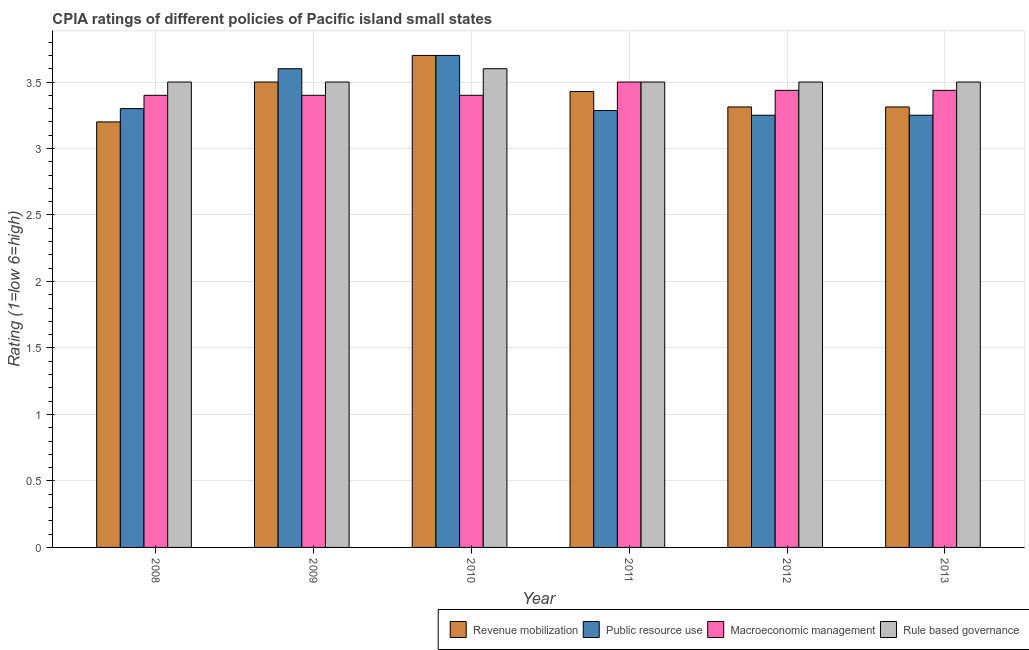How many groups of bars are there?
Ensure brevity in your answer.  6. Are the number of bars per tick equal to the number of legend labels?
Your answer should be very brief. Yes. How many bars are there on the 1st tick from the right?
Offer a very short reply. 4. What is the cpia rating of public resource use in 2011?
Keep it short and to the point. 3.29. Across all years, what is the maximum cpia rating of rule based governance?
Keep it short and to the point. 3.6. In which year was the cpia rating of macroeconomic management maximum?
Your answer should be compact. 2011. What is the total cpia rating of public resource use in the graph?
Your response must be concise. 20.39. What is the difference between the cpia rating of revenue mobilization in 2012 and the cpia rating of rule based governance in 2011?
Your response must be concise. -0.12. What is the average cpia rating of revenue mobilization per year?
Your answer should be very brief. 3.41. What is the ratio of the cpia rating of rule based governance in 2010 to that in 2012?
Ensure brevity in your answer.  1.03. Is the difference between the cpia rating of revenue mobilization in 2009 and 2013 greater than the difference between the cpia rating of rule based governance in 2009 and 2013?
Keep it short and to the point. No. What is the difference between the highest and the second highest cpia rating of rule based governance?
Offer a very short reply. 0.1. What is the difference between the highest and the lowest cpia rating of rule based governance?
Provide a short and direct response. 0.1. Is the sum of the cpia rating of public resource use in 2009 and 2011 greater than the maximum cpia rating of rule based governance across all years?
Keep it short and to the point. Yes. What does the 4th bar from the left in 2011 represents?
Your answer should be compact. Rule based governance. What does the 3rd bar from the right in 2008 represents?
Provide a short and direct response. Public resource use. Is it the case that in every year, the sum of the cpia rating of revenue mobilization and cpia rating of public resource use is greater than the cpia rating of macroeconomic management?
Make the answer very short. Yes. Are all the bars in the graph horizontal?
Your response must be concise. No. How many years are there in the graph?
Your answer should be compact. 6. Are the values on the major ticks of Y-axis written in scientific E-notation?
Make the answer very short. No. Does the graph contain any zero values?
Keep it short and to the point. No. How are the legend labels stacked?
Offer a very short reply. Horizontal. What is the title of the graph?
Your answer should be compact. CPIA ratings of different policies of Pacific island small states. What is the label or title of the Y-axis?
Give a very brief answer. Rating (1=low 6=high). What is the Rating (1=low 6=high) in Revenue mobilization in 2008?
Offer a very short reply. 3.2. What is the Rating (1=low 6=high) in Public resource use in 2008?
Your response must be concise. 3.3. What is the Rating (1=low 6=high) of Macroeconomic management in 2008?
Offer a very short reply. 3.4. What is the Rating (1=low 6=high) of Revenue mobilization in 2009?
Offer a terse response. 3.5. What is the Rating (1=low 6=high) in Public resource use in 2009?
Your response must be concise. 3.6. What is the Rating (1=low 6=high) of Revenue mobilization in 2010?
Provide a succinct answer. 3.7. What is the Rating (1=low 6=high) in Rule based governance in 2010?
Your answer should be very brief. 3.6. What is the Rating (1=low 6=high) in Revenue mobilization in 2011?
Give a very brief answer. 3.43. What is the Rating (1=low 6=high) in Public resource use in 2011?
Provide a succinct answer. 3.29. What is the Rating (1=low 6=high) of Macroeconomic management in 2011?
Your answer should be very brief. 3.5. What is the Rating (1=low 6=high) of Rule based governance in 2011?
Make the answer very short. 3.5. What is the Rating (1=low 6=high) of Revenue mobilization in 2012?
Your answer should be compact. 3.31. What is the Rating (1=low 6=high) in Macroeconomic management in 2012?
Offer a terse response. 3.44. What is the Rating (1=low 6=high) of Rule based governance in 2012?
Your answer should be compact. 3.5. What is the Rating (1=low 6=high) in Revenue mobilization in 2013?
Your response must be concise. 3.31. What is the Rating (1=low 6=high) of Public resource use in 2013?
Offer a very short reply. 3.25. What is the Rating (1=low 6=high) in Macroeconomic management in 2013?
Give a very brief answer. 3.44. Across all years, what is the maximum Rating (1=low 6=high) of Macroeconomic management?
Provide a short and direct response. 3.5. Across all years, what is the minimum Rating (1=low 6=high) in Macroeconomic management?
Make the answer very short. 3.4. What is the total Rating (1=low 6=high) of Revenue mobilization in the graph?
Provide a succinct answer. 20.45. What is the total Rating (1=low 6=high) in Public resource use in the graph?
Your answer should be very brief. 20.39. What is the total Rating (1=low 6=high) of Macroeconomic management in the graph?
Your answer should be very brief. 20.57. What is the total Rating (1=low 6=high) of Rule based governance in the graph?
Provide a short and direct response. 21.1. What is the difference between the Rating (1=low 6=high) of Public resource use in 2008 and that in 2009?
Give a very brief answer. -0.3. What is the difference between the Rating (1=low 6=high) of Macroeconomic management in 2008 and that in 2009?
Your response must be concise. 0. What is the difference between the Rating (1=low 6=high) in Rule based governance in 2008 and that in 2009?
Make the answer very short. 0. What is the difference between the Rating (1=low 6=high) in Macroeconomic management in 2008 and that in 2010?
Provide a succinct answer. 0. What is the difference between the Rating (1=low 6=high) of Rule based governance in 2008 and that in 2010?
Offer a terse response. -0.1. What is the difference between the Rating (1=low 6=high) of Revenue mobilization in 2008 and that in 2011?
Provide a succinct answer. -0.23. What is the difference between the Rating (1=low 6=high) of Public resource use in 2008 and that in 2011?
Provide a short and direct response. 0.01. What is the difference between the Rating (1=low 6=high) of Revenue mobilization in 2008 and that in 2012?
Keep it short and to the point. -0.11. What is the difference between the Rating (1=low 6=high) in Public resource use in 2008 and that in 2012?
Ensure brevity in your answer.  0.05. What is the difference between the Rating (1=low 6=high) of Macroeconomic management in 2008 and that in 2012?
Provide a succinct answer. -0.04. What is the difference between the Rating (1=low 6=high) in Revenue mobilization in 2008 and that in 2013?
Offer a terse response. -0.11. What is the difference between the Rating (1=low 6=high) in Macroeconomic management in 2008 and that in 2013?
Your answer should be very brief. -0.04. What is the difference between the Rating (1=low 6=high) in Public resource use in 2009 and that in 2010?
Give a very brief answer. -0.1. What is the difference between the Rating (1=low 6=high) in Macroeconomic management in 2009 and that in 2010?
Provide a succinct answer. 0. What is the difference between the Rating (1=low 6=high) in Rule based governance in 2009 and that in 2010?
Offer a terse response. -0.1. What is the difference between the Rating (1=low 6=high) of Revenue mobilization in 2009 and that in 2011?
Keep it short and to the point. 0.07. What is the difference between the Rating (1=low 6=high) in Public resource use in 2009 and that in 2011?
Your answer should be very brief. 0.31. What is the difference between the Rating (1=low 6=high) in Macroeconomic management in 2009 and that in 2011?
Provide a short and direct response. -0.1. What is the difference between the Rating (1=low 6=high) in Rule based governance in 2009 and that in 2011?
Ensure brevity in your answer.  0. What is the difference between the Rating (1=low 6=high) in Revenue mobilization in 2009 and that in 2012?
Your answer should be very brief. 0.19. What is the difference between the Rating (1=low 6=high) in Macroeconomic management in 2009 and that in 2012?
Provide a short and direct response. -0.04. What is the difference between the Rating (1=low 6=high) of Rule based governance in 2009 and that in 2012?
Provide a succinct answer. 0. What is the difference between the Rating (1=low 6=high) of Revenue mobilization in 2009 and that in 2013?
Keep it short and to the point. 0.19. What is the difference between the Rating (1=low 6=high) in Macroeconomic management in 2009 and that in 2013?
Offer a very short reply. -0.04. What is the difference between the Rating (1=low 6=high) in Revenue mobilization in 2010 and that in 2011?
Your answer should be compact. 0.27. What is the difference between the Rating (1=low 6=high) of Public resource use in 2010 and that in 2011?
Your response must be concise. 0.41. What is the difference between the Rating (1=low 6=high) in Macroeconomic management in 2010 and that in 2011?
Provide a succinct answer. -0.1. What is the difference between the Rating (1=low 6=high) in Rule based governance in 2010 and that in 2011?
Offer a very short reply. 0.1. What is the difference between the Rating (1=low 6=high) in Revenue mobilization in 2010 and that in 2012?
Your response must be concise. 0.39. What is the difference between the Rating (1=low 6=high) in Public resource use in 2010 and that in 2012?
Give a very brief answer. 0.45. What is the difference between the Rating (1=low 6=high) of Macroeconomic management in 2010 and that in 2012?
Give a very brief answer. -0.04. What is the difference between the Rating (1=low 6=high) in Rule based governance in 2010 and that in 2012?
Your response must be concise. 0.1. What is the difference between the Rating (1=low 6=high) in Revenue mobilization in 2010 and that in 2013?
Make the answer very short. 0.39. What is the difference between the Rating (1=low 6=high) of Public resource use in 2010 and that in 2013?
Ensure brevity in your answer.  0.45. What is the difference between the Rating (1=low 6=high) in Macroeconomic management in 2010 and that in 2013?
Make the answer very short. -0.04. What is the difference between the Rating (1=low 6=high) of Rule based governance in 2010 and that in 2013?
Make the answer very short. 0.1. What is the difference between the Rating (1=low 6=high) of Revenue mobilization in 2011 and that in 2012?
Give a very brief answer. 0.12. What is the difference between the Rating (1=low 6=high) in Public resource use in 2011 and that in 2012?
Ensure brevity in your answer.  0.04. What is the difference between the Rating (1=low 6=high) in Macroeconomic management in 2011 and that in 2012?
Give a very brief answer. 0.06. What is the difference between the Rating (1=low 6=high) of Revenue mobilization in 2011 and that in 2013?
Offer a very short reply. 0.12. What is the difference between the Rating (1=low 6=high) of Public resource use in 2011 and that in 2013?
Your response must be concise. 0.04. What is the difference between the Rating (1=low 6=high) of Macroeconomic management in 2011 and that in 2013?
Your response must be concise. 0.06. What is the difference between the Rating (1=low 6=high) in Rule based governance in 2011 and that in 2013?
Your response must be concise. 0. What is the difference between the Rating (1=low 6=high) in Revenue mobilization in 2012 and that in 2013?
Provide a succinct answer. 0. What is the difference between the Rating (1=low 6=high) of Macroeconomic management in 2012 and that in 2013?
Provide a succinct answer. 0. What is the difference between the Rating (1=low 6=high) in Rule based governance in 2012 and that in 2013?
Keep it short and to the point. 0. What is the difference between the Rating (1=low 6=high) of Revenue mobilization in 2008 and the Rating (1=low 6=high) of Rule based governance in 2009?
Make the answer very short. -0.3. What is the difference between the Rating (1=low 6=high) of Public resource use in 2008 and the Rating (1=low 6=high) of Macroeconomic management in 2009?
Give a very brief answer. -0.1. What is the difference between the Rating (1=low 6=high) of Revenue mobilization in 2008 and the Rating (1=low 6=high) of Public resource use in 2010?
Offer a terse response. -0.5. What is the difference between the Rating (1=low 6=high) of Public resource use in 2008 and the Rating (1=low 6=high) of Macroeconomic management in 2010?
Provide a short and direct response. -0.1. What is the difference between the Rating (1=low 6=high) of Macroeconomic management in 2008 and the Rating (1=low 6=high) of Rule based governance in 2010?
Your answer should be compact. -0.2. What is the difference between the Rating (1=low 6=high) of Revenue mobilization in 2008 and the Rating (1=low 6=high) of Public resource use in 2011?
Your response must be concise. -0.09. What is the difference between the Rating (1=low 6=high) of Revenue mobilization in 2008 and the Rating (1=low 6=high) of Macroeconomic management in 2011?
Your answer should be compact. -0.3. What is the difference between the Rating (1=low 6=high) of Revenue mobilization in 2008 and the Rating (1=low 6=high) of Rule based governance in 2011?
Make the answer very short. -0.3. What is the difference between the Rating (1=low 6=high) of Public resource use in 2008 and the Rating (1=low 6=high) of Macroeconomic management in 2011?
Provide a short and direct response. -0.2. What is the difference between the Rating (1=low 6=high) in Revenue mobilization in 2008 and the Rating (1=low 6=high) in Public resource use in 2012?
Provide a succinct answer. -0.05. What is the difference between the Rating (1=low 6=high) of Revenue mobilization in 2008 and the Rating (1=low 6=high) of Macroeconomic management in 2012?
Your answer should be very brief. -0.24. What is the difference between the Rating (1=low 6=high) in Public resource use in 2008 and the Rating (1=low 6=high) in Macroeconomic management in 2012?
Offer a terse response. -0.14. What is the difference between the Rating (1=low 6=high) of Revenue mobilization in 2008 and the Rating (1=low 6=high) of Public resource use in 2013?
Offer a very short reply. -0.05. What is the difference between the Rating (1=low 6=high) of Revenue mobilization in 2008 and the Rating (1=low 6=high) of Macroeconomic management in 2013?
Ensure brevity in your answer.  -0.24. What is the difference between the Rating (1=low 6=high) of Revenue mobilization in 2008 and the Rating (1=low 6=high) of Rule based governance in 2013?
Your response must be concise. -0.3. What is the difference between the Rating (1=low 6=high) of Public resource use in 2008 and the Rating (1=low 6=high) of Macroeconomic management in 2013?
Offer a very short reply. -0.14. What is the difference between the Rating (1=low 6=high) of Public resource use in 2008 and the Rating (1=low 6=high) of Rule based governance in 2013?
Your answer should be compact. -0.2. What is the difference between the Rating (1=low 6=high) in Revenue mobilization in 2009 and the Rating (1=low 6=high) in Rule based governance in 2010?
Offer a terse response. -0.1. What is the difference between the Rating (1=low 6=high) of Public resource use in 2009 and the Rating (1=low 6=high) of Macroeconomic management in 2010?
Your answer should be very brief. 0.2. What is the difference between the Rating (1=low 6=high) in Revenue mobilization in 2009 and the Rating (1=low 6=high) in Public resource use in 2011?
Your answer should be very brief. 0.21. What is the difference between the Rating (1=low 6=high) in Revenue mobilization in 2009 and the Rating (1=low 6=high) in Macroeconomic management in 2011?
Offer a terse response. 0. What is the difference between the Rating (1=low 6=high) in Revenue mobilization in 2009 and the Rating (1=low 6=high) in Macroeconomic management in 2012?
Ensure brevity in your answer.  0.06. What is the difference between the Rating (1=low 6=high) in Public resource use in 2009 and the Rating (1=low 6=high) in Macroeconomic management in 2012?
Keep it short and to the point. 0.16. What is the difference between the Rating (1=low 6=high) of Public resource use in 2009 and the Rating (1=low 6=high) of Rule based governance in 2012?
Your response must be concise. 0.1. What is the difference between the Rating (1=low 6=high) of Macroeconomic management in 2009 and the Rating (1=low 6=high) of Rule based governance in 2012?
Make the answer very short. -0.1. What is the difference between the Rating (1=low 6=high) of Revenue mobilization in 2009 and the Rating (1=low 6=high) of Macroeconomic management in 2013?
Provide a short and direct response. 0.06. What is the difference between the Rating (1=low 6=high) of Revenue mobilization in 2009 and the Rating (1=low 6=high) of Rule based governance in 2013?
Your response must be concise. 0. What is the difference between the Rating (1=low 6=high) in Public resource use in 2009 and the Rating (1=low 6=high) in Macroeconomic management in 2013?
Your answer should be compact. 0.16. What is the difference between the Rating (1=low 6=high) in Public resource use in 2009 and the Rating (1=low 6=high) in Rule based governance in 2013?
Make the answer very short. 0.1. What is the difference between the Rating (1=low 6=high) of Macroeconomic management in 2009 and the Rating (1=low 6=high) of Rule based governance in 2013?
Make the answer very short. -0.1. What is the difference between the Rating (1=low 6=high) in Revenue mobilization in 2010 and the Rating (1=low 6=high) in Public resource use in 2011?
Your answer should be compact. 0.41. What is the difference between the Rating (1=low 6=high) of Revenue mobilization in 2010 and the Rating (1=low 6=high) of Rule based governance in 2011?
Offer a very short reply. 0.2. What is the difference between the Rating (1=low 6=high) of Public resource use in 2010 and the Rating (1=low 6=high) of Macroeconomic management in 2011?
Your response must be concise. 0.2. What is the difference between the Rating (1=low 6=high) of Public resource use in 2010 and the Rating (1=low 6=high) of Rule based governance in 2011?
Your answer should be compact. 0.2. What is the difference between the Rating (1=low 6=high) in Macroeconomic management in 2010 and the Rating (1=low 6=high) in Rule based governance in 2011?
Offer a terse response. -0.1. What is the difference between the Rating (1=low 6=high) in Revenue mobilization in 2010 and the Rating (1=low 6=high) in Public resource use in 2012?
Provide a short and direct response. 0.45. What is the difference between the Rating (1=low 6=high) of Revenue mobilization in 2010 and the Rating (1=low 6=high) of Macroeconomic management in 2012?
Give a very brief answer. 0.26. What is the difference between the Rating (1=low 6=high) of Revenue mobilization in 2010 and the Rating (1=low 6=high) of Rule based governance in 2012?
Offer a very short reply. 0.2. What is the difference between the Rating (1=low 6=high) of Public resource use in 2010 and the Rating (1=low 6=high) of Macroeconomic management in 2012?
Keep it short and to the point. 0.26. What is the difference between the Rating (1=low 6=high) in Macroeconomic management in 2010 and the Rating (1=low 6=high) in Rule based governance in 2012?
Your answer should be compact. -0.1. What is the difference between the Rating (1=low 6=high) of Revenue mobilization in 2010 and the Rating (1=low 6=high) of Public resource use in 2013?
Provide a succinct answer. 0.45. What is the difference between the Rating (1=low 6=high) of Revenue mobilization in 2010 and the Rating (1=low 6=high) of Macroeconomic management in 2013?
Provide a succinct answer. 0.26. What is the difference between the Rating (1=low 6=high) in Revenue mobilization in 2010 and the Rating (1=low 6=high) in Rule based governance in 2013?
Your response must be concise. 0.2. What is the difference between the Rating (1=low 6=high) in Public resource use in 2010 and the Rating (1=low 6=high) in Macroeconomic management in 2013?
Provide a succinct answer. 0.26. What is the difference between the Rating (1=low 6=high) in Macroeconomic management in 2010 and the Rating (1=low 6=high) in Rule based governance in 2013?
Your answer should be very brief. -0.1. What is the difference between the Rating (1=low 6=high) of Revenue mobilization in 2011 and the Rating (1=low 6=high) of Public resource use in 2012?
Provide a succinct answer. 0.18. What is the difference between the Rating (1=low 6=high) of Revenue mobilization in 2011 and the Rating (1=low 6=high) of Macroeconomic management in 2012?
Your answer should be very brief. -0.01. What is the difference between the Rating (1=low 6=high) of Revenue mobilization in 2011 and the Rating (1=low 6=high) of Rule based governance in 2012?
Your answer should be compact. -0.07. What is the difference between the Rating (1=low 6=high) of Public resource use in 2011 and the Rating (1=low 6=high) of Macroeconomic management in 2012?
Provide a succinct answer. -0.15. What is the difference between the Rating (1=low 6=high) in Public resource use in 2011 and the Rating (1=low 6=high) in Rule based governance in 2012?
Your response must be concise. -0.21. What is the difference between the Rating (1=low 6=high) of Macroeconomic management in 2011 and the Rating (1=low 6=high) of Rule based governance in 2012?
Ensure brevity in your answer.  0. What is the difference between the Rating (1=low 6=high) in Revenue mobilization in 2011 and the Rating (1=low 6=high) in Public resource use in 2013?
Keep it short and to the point. 0.18. What is the difference between the Rating (1=low 6=high) of Revenue mobilization in 2011 and the Rating (1=low 6=high) of Macroeconomic management in 2013?
Offer a terse response. -0.01. What is the difference between the Rating (1=low 6=high) in Revenue mobilization in 2011 and the Rating (1=low 6=high) in Rule based governance in 2013?
Your response must be concise. -0.07. What is the difference between the Rating (1=low 6=high) of Public resource use in 2011 and the Rating (1=low 6=high) of Macroeconomic management in 2013?
Offer a very short reply. -0.15. What is the difference between the Rating (1=low 6=high) of Public resource use in 2011 and the Rating (1=low 6=high) of Rule based governance in 2013?
Make the answer very short. -0.21. What is the difference between the Rating (1=low 6=high) in Revenue mobilization in 2012 and the Rating (1=low 6=high) in Public resource use in 2013?
Your response must be concise. 0.06. What is the difference between the Rating (1=low 6=high) in Revenue mobilization in 2012 and the Rating (1=low 6=high) in Macroeconomic management in 2013?
Provide a succinct answer. -0.12. What is the difference between the Rating (1=low 6=high) in Revenue mobilization in 2012 and the Rating (1=low 6=high) in Rule based governance in 2013?
Your answer should be compact. -0.19. What is the difference between the Rating (1=low 6=high) in Public resource use in 2012 and the Rating (1=low 6=high) in Macroeconomic management in 2013?
Offer a terse response. -0.19. What is the difference between the Rating (1=low 6=high) in Macroeconomic management in 2012 and the Rating (1=low 6=high) in Rule based governance in 2013?
Ensure brevity in your answer.  -0.06. What is the average Rating (1=low 6=high) of Revenue mobilization per year?
Keep it short and to the point. 3.41. What is the average Rating (1=low 6=high) in Public resource use per year?
Keep it short and to the point. 3.4. What is the average Rating (1=low 6=high) in Macroeconomic management per year?
Provide a succinct answer. 3.43. What is the average Rating (1=low 6=high) of Rule based governance per year?
Your answer should be compact. 3.52. In the year 2008, what is the difference between the Rating (1=low 6=high) of Public resource use and Rating (1=low 6=high) of Macroeconomic management?
Provide a short and direct response. -0.1. In the year 2008, what is the difference between the Rating (1=low 6=high) in Macroeconomic management and Rating (1=low 6=high) in Rule based governance?
Offer a terse response. -0.1. In the year 2009, what is the difference between the Rating (1=low 6=high) of Macroeconomic management and Rating (1=low 6=high) of Rule based governance?
Give a very brief answer. -0.1. In the year 2010, what is the difference between the Rating (1=low 6=high) in Revenue mobilization and Rating (1=low 6=high) in Macroeconomic management?
Offer a very short reply. 0.3. In the year 2010, what is the difference between the Rating (1=low 6=high) of Public resource use and Rating (1=low 6=high) of Macroeconomic management?
Ensure brevity in your answer.  0.3. In the year 2010, what is the difference between the Rating (1=low 6=high) of Public resource use and Rating (1=low 6=high) of Rule based governance?
Offer a terse response. 0.1. In the year 2010, what is the difference between the Rating (1=low 6=high) in Macroeconomic management and Rating (1=low 6=high) in Rule based governance?
Ensure brevity in your answer.  -0.2. In the year 2011, what is the difference between the Rating (1=low 6=high) in Revenue mobilization and Rating (1=low 6=high) in Public resource use?
Your answer should be compact. 0.14. In the year 2011, what is the difference between the Rating (1=low 6=high) of Revenue mobilization and Rating (1=low 6=high) of Macroeconomic management?
Your answer should be compact. -0.07. In the year 2011, what is the difference between the Rating (1=low 6=high) in Revenue mobilization and Rating (1=low 6=high) in Rule based governance?
Make the answer very short. -0.07. In the year 2011, what is the difference between the Rating (1=low 6=high) in Public resource use and Rating (1=low 6=high) in Macroeconomic management?
Your answer should be very brief. -0.21. In the year 2011, what is the difference between the Rating (1=low 6=high) in Public resource use and Rating (1=low 6=high) in Rule based governance?
Offer a terse response. -0.21. In the year 2011, what is the difference between the Rating (1=low 6=high) in Macroeconomic management and Rating (1=low 6=high) in Rule based governance?
Keep it short and to the point. 0. In the year 2012, what is the difference between the Rating (1=low 6=high) in Revenue mobilization and Rating (1=low 6=high) in Public resource use?
Ensure brevity in your answer.  0.06. In the year 2012, what is the difference between the Rating (1=low 6=high) of Revenue mobilization and Rating (1=low 6=high) of Macroeconomic management?
Your response must be concise. -0.12. In the year 2012, what is the difference between the Rating (1=low 6=high) of Revenue mobilization and Rating (1=low 6=high) of Rule based governance?
Provide a short and direct response. -0.19. In the year 2012, what is the difference between the Rating (1=low 6=high) of Public resource use and Rating (1=low 6=high) of Macroeconomic management?
Your answer should be very brief. -0.19. In the year 2012, what is the difference between the Rating (1=low 6=high) in Macroeconomic management and Rating (1=low 6=high) in Rule based governance?
Offer a very short reply. -0.06. In the year 2013, what is the difference between the Rating (1=low 6=high) in Revenue mobilization and Rating (1=low 6=high) in Public resource use?
Offer a terse response. 0.06. In the year 2013, what is the difference between the Rating (1=low 6=high) in Revenue mobilization and Rating (1=low 6=high) in Macroeconomic management?
Your response must be concise. -0.12. In the year 2013, what is the difference between the Rating (1=low 6=high) in Revenue mobilization and Rating (1=low 6=high) in Rule based governance?
Offer a terse response. -0.19. In the year 2013, what is the difference between the Rating (1=low 6=high) of Public resource use and Rating (1=low 6=high) of Macroeconomic management?
Give a very brief answer. -0.19. In the year 2013, what is the difference between the Rating (1=low 6=high) in Macroeconomic management and Rating (1=low 6=high) in Rule based governance?
Your answer should be very brief. -0.06. What is the ratio of the Rating (1=low 6=high) in Revenue mobilization in 2008 to that in 2009?
Provide a short and direct response. 0.91. What is the ratio of the Rating (1=low 6=high) in Public resource use in 2008 to that in 2009?
Your response must be concise. 0.92. What is the ratio of the Rating (1=low 6=high) of Macroeconomic management in 2008 to that in 2009?
Ensure brevity in your answer.  1. What is the ratio of the Rating (1=low 6=high) in Rule based governance in 2008 to that in 2009?
Offer a very short reply. 1. What is the ratio of the Rating (1=low 6=high) in Revenue mobilization in 2008 to that in 2010?
Ensure brevity in your answer.  0.86. What is the ratio of the Rating (1=low 6=high) in Public resource use in 2008 to that in 2010?
Your response must be concise. 0.89. What is the ratio of the Rating (1=low 6=high) in Rule based governance in 2008 to that in 2010?
Provide a short and direct response. 0.97. What is the ratio of the Rating (1=low 6=high) of Public resource use in 2008 to that in 2011?
Your answer should be very brief. 1. What is the ratio of the Rating (1=low 6=high) in Macroeconomic management in 2008 to that in 2011?
Your answer should be very brief. 0.97. What is the ratio of the Rating (1=low 6=high) of Public resource use in 2008 to that in 2012?
Your response must be concise. 1.02. What is the ratio of the Rating (1=low 6=high) of Rule based governance in 2008 to that in 2012?
Offer a terse response. 1. What is the ratio of the Rating (1=low 6=high) in Revenue mobilization in 2008 to that in 2013?
Make the answer very short. 0.97. What is the ratio of the Rating (1=low 6=high) in Public resource use in 2008 to that in 2013?
Keep it short and to the point. 1.02. What is the ratio of the Rating (1=low 6=high) in Macroeconomic management in 2008 to that in 2013?
Ensure brevity in your answer.  0.99. What is the ratio of the Rating (1=low 6=high) of Rule based governance in 2008 to that in 2013?
Offer a terse response. 1. What is the ratio of the Rating (1=low 6=high) in Revenue mobilization in 2009 to that in 2010?
Offer a very short reply. 0.95. What is the ratio of the Rating (1=low 6=high) in Rule based governance in 2009 to that in 2010?
Offer a terse response. 0.97. What is the ratio of the Rating (1=low 6=high) in Revenue mobilization in 2009 to that in 2011?
Offer a very short reply. 1.02. What is the ratio of the Rating (1=low 6=high) in Public resource use in 2009 to that in 2011?
Your answer should be very brief. 1.1. What is the ratio of the Rating (1=low 6=high) of Macroeconomic management in 2009 to that in 2011?
Ensure brevity in your answer.  0.97. What is the ratio of the Rating (1=low 6=high) in Revenue mobilization in 2009 to that in 2012?
Ensure brevity in your answer.  1.06. What is the ratio of the Rating (1=low 6=high) in Public resource use in 2009 to that in 2012?
Keep it short and to the point. 1.11. What is the ratio of the Rating (1=low 6=high) in Revenue mobilization in 2009 to that in 2013?
Offer a very short reply. 1.06. What is the ratio of the Rating (1=low 6=high) in Public resource use in 2009 to that in 2013?
Offer a terse response. 1.11. What is the ratio of the Rating (1=low 6=high) of Revenue mobilization in 2010 to that in 2011?
Offer a very short reply. 1.08. What is the ratio of the Rating (1=low 6=high) of Public resource use in 2010 to that in 2011?
Make the answer very short. 1.13. What is the ratio of the Rating (1=low 6=high) of Macroeconomic management in 2010 to that in 2011?
Provide a succinct answer. 0.97. What is the ratio of the Rating (1=low 6=high) in Rule based governance in 2010 to that in 2011?
Provide a short and direct response. 1.03. What is the ratio of the Rating (1=low 6=high) of Revenue mobilization in 2010 to that in 2012?
Your answer should be compact. 1.12. What is the ratio of the Rating (1=low 6=high) in Public resource use in 2010 to that in 2012?
Ensure brevity in your answer.  1.14. What is the ratio of the Rating (1=low 6=high) of Rule based governance in 2010 to that in 2012?
Provide a short and direct response. 1.03. What is the ratio of the Rating (1=low 6=high) of Revenue mobilization in 2010 to that in 2013?
Ensure brevity in your answer.  1.12. What is the ratio of the Rating (1=low 6=high) in Public resource use in 2010 to that in 2013?
Offer a terse response. 1.14. What is the ratio of the Rating (1=low 6=high) of Rule based governance in 2010 to that in 2013?
Your answer should be very brief. 1.03. What is the ratio of the Rating (1=low 6=high) in Revenue mobilization in 2011 to that in 2012?
Offer a very short reply. 1.03. What is the ratio of the Rating (1=low 6=high) of Public resource use in 2011 to that in 2012?
Make the answer very short. 1.01. What is the ratio of the Rating (1=low 6=high) in Macroeconomic management in 2011 to that in 2012?
Offer a very short reply. 1.02. What is the ratio of the Rating (1=low 6=high) of Rule based governance in 2011 to that in 2012?
Give a very brief answer. 1. What is the ratio of the Rating (1=low 6=high) in Revenue mobilization in 2011 to that in 2013?
Ensure brevity in your answer.  1.03. What is the ratio of the Rating (1=low 6=high) in Public resource use in 2011 to that in 2013?
Provide a short and direct response. 1.01. What is the ratio of the Rating (1=low 6=high) of Macroeconomic management in 2011 to that in 2013?
Your answer should be very brief. 1.02. What is the ratio of the Rating (1=low 6=high) of Revenue mobilization in 2012 to that in 2013?
Give a very brief answer. 1. What is the ratio of the Rating (1=low 6=high) in Rule based governance in 2012 to that in 2013?
Provide a succinct answer. 1. What is the difference between the highest and the second highest Rating (1=low 6=high) of Revenue mobilization?
Your answer should be compact. 0.2. What is the difference between the highest and the second highest Rating (1=low 6=high) of Macroeconomic management?
Your answer should be very brief. 0.06. What is the difference between the highest and the lowest Rating (1=low 6=high) in Public resource use?
Provide a succinct answer. 0.45. What is the difference between the highest and the lowest Rating (1=low 6=high) of Macroeconomic management?
Provide a short and direct response. 0.1. 